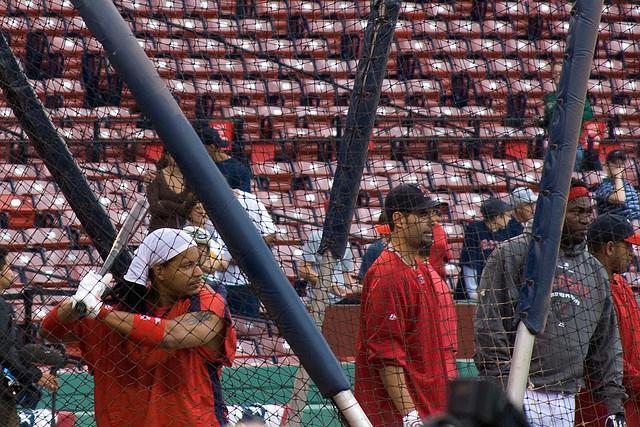How many people are there?
Give a very brief answer. 9. 